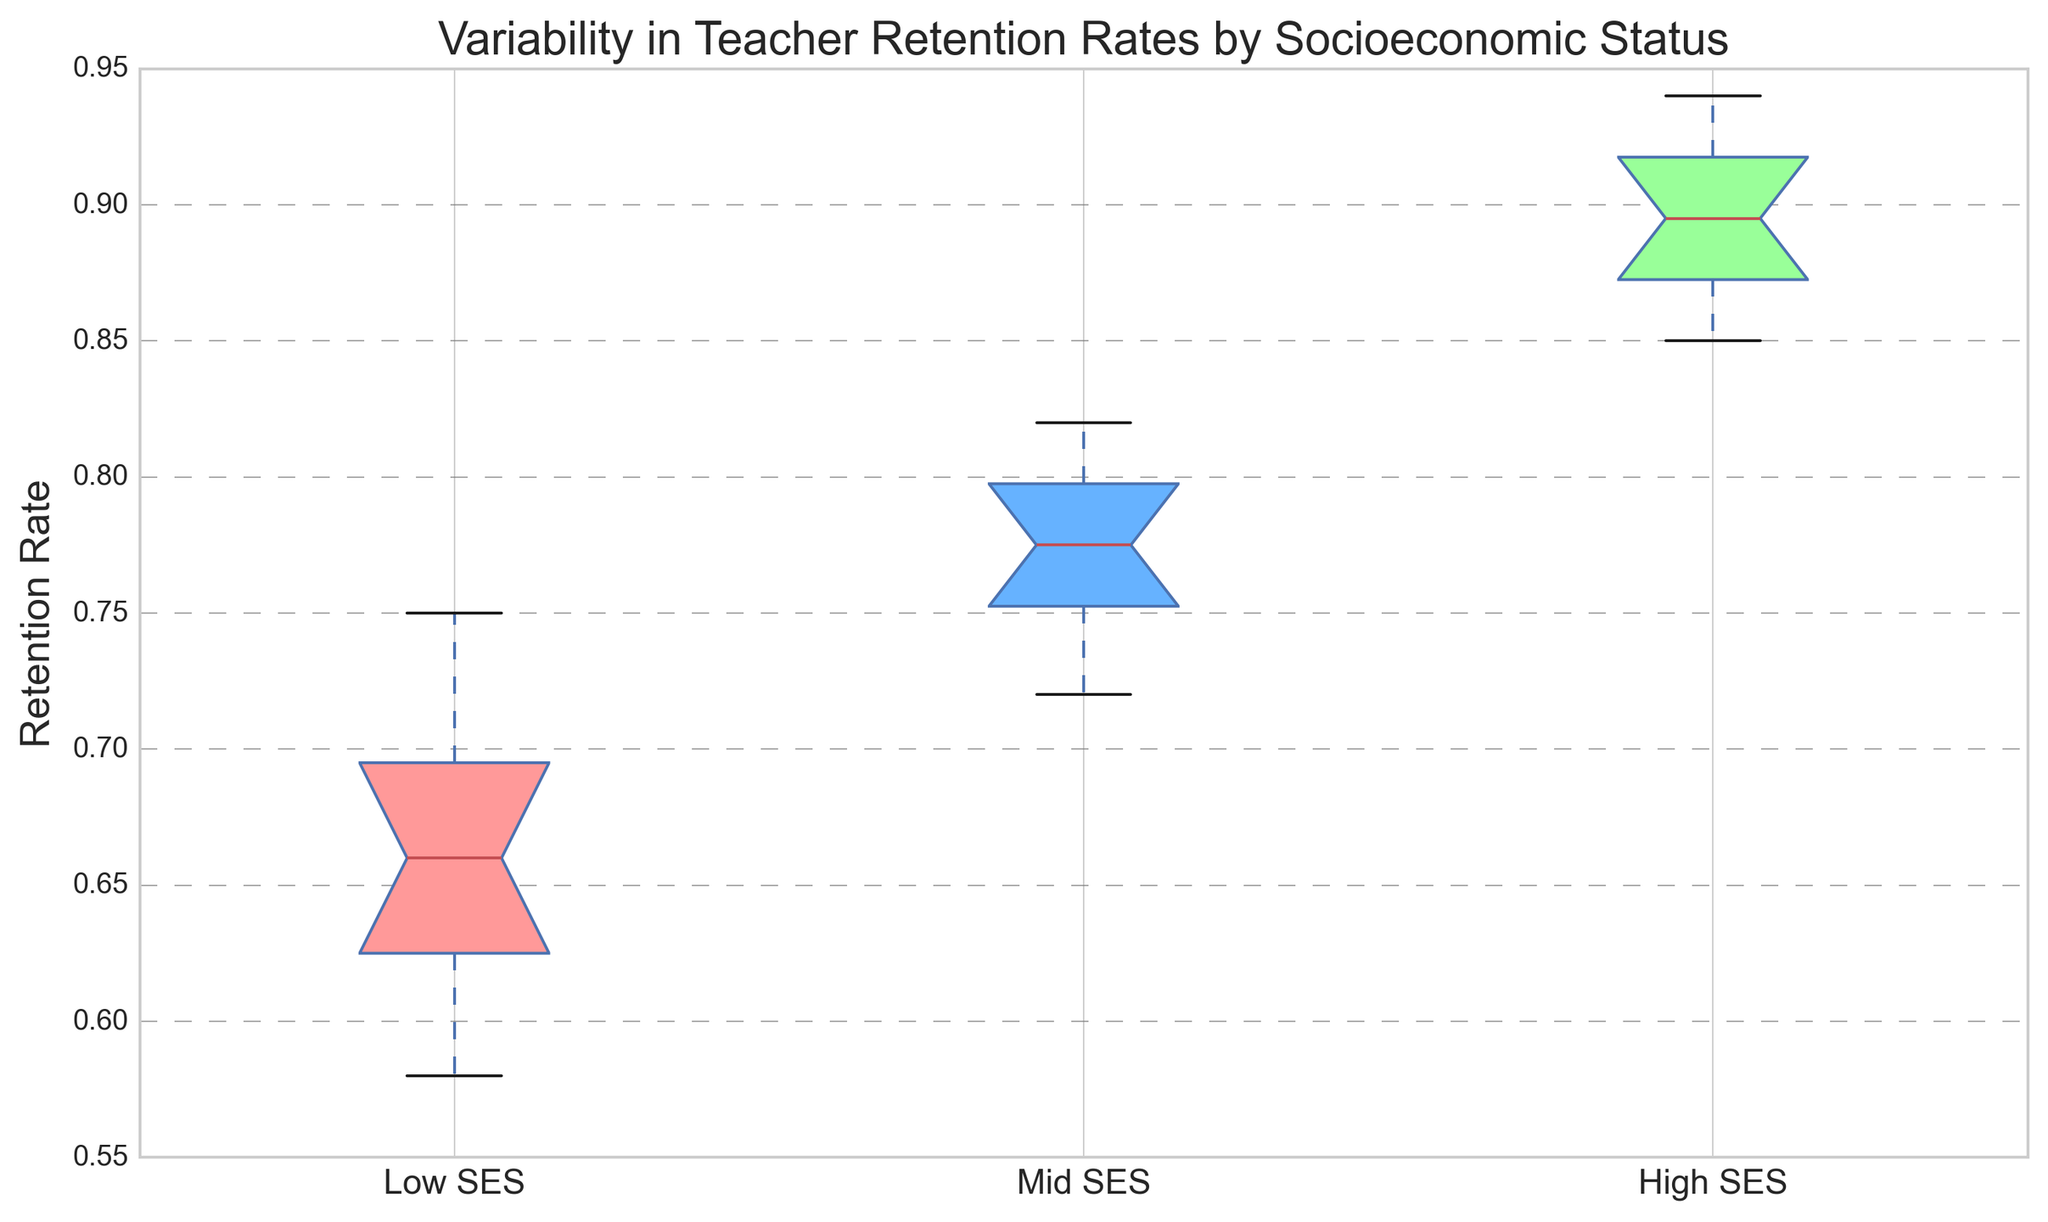What is the median retention rate for the High SES group? The median in a box plot is represented by the line inside the box. Observing the box plot for the High SES group, the line inside the box indicates the median retention rate.
Answer: Around 0.89 Between which groups is the difference in median retention rates the greatest? By identifying the median line in each box plot, observe the medians of the Low, Mid, and High SES groups. Calculate the differences: High SES and Low SES, and High SES and Mid SES. The difference between High SES and Low SES medians is the largest.
Answer: High SES and Low SES What can you infer about the spread of retention rates in the Mid SES group compared to the Low SES group? Observe the width of the boxes (interquartile range) and the length of the whiskers in both groups. Mid SES has a smaller box and shorter whiskers, indicating less variability.
Answer: Mid SES has less spread Which group has the lowest minimum retention rate, and what is it approximately? The minimum in a box plot is the bottom whisker. For the Low, Mid, and High SES groups, observe the bottom of each whisker and identify the lowest point. The Low SES group has the lowest minimum retention rate.
Answer: Low SES, around 0.58 Based on the figure, which group shows the highest maximum retention rate? The maximum is indicated by the top whisker in each box plot. Observing the box plots for each group, the High SES group has the highest whisker.
Answer: High SES How does the interquartile range (IQR) of the Low SES group compare to the Mid SES group? The IQR is the range between the first (bottom of the box) and third quartiles (top of the box). Comparing the IQRs: the Low SES group has a wider box than the Mid SES group, indicating a larger IQR.
Answer: Low SES has a larger IQR What retention rate values would be considered outliers in the Mid SES group, if any? Outliers are typically represented by points outside the whiskers. Observing the Mid SES group box plot, there are no points outside the whiskers, so there are no outliers.
Answer: None Which SES group has the widest range of retention rates and what is the approximate range for that group? The range is the difference between the minimum and maximum values (whiskers). The Low SES group has the widest range. Measure the difference between the top and bottom whiskers. Approximately from 0.58 to 0.75.
Answer: Low SES, around 0.17 Comparing the retention rates, which SES group has the most consistent teacher retention rates? Consistency is indicated by a smaller spread and interquartile range. The box plot for the High SES group shows the smallest spread and IQR, indicating the most consistent retention rates.
Answer: High SES What does the notch in the box plot indicate, and what can you infer from the notches of the SES groups? The notch represents the confidence interval around the median. If notches between box plots do not overlap, the medians are significantly different. The notches of Low SES and High SES do not overlap, indicating a significant difference in medians.
Answer: Indicates significant difference in medians between Low and High SES 